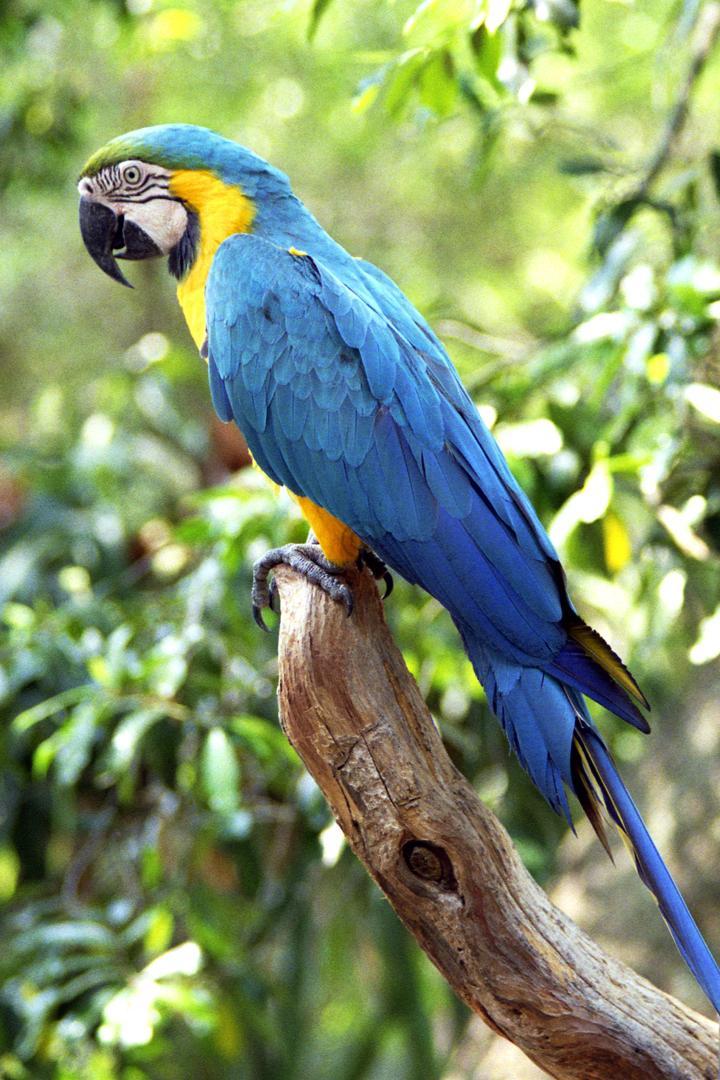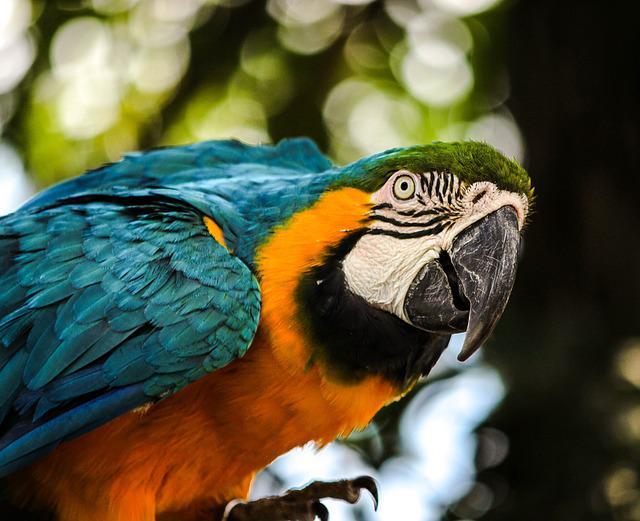The first image is the image on the left, the second image is the image on the right. For the images shown, is this caption "All birds shown have blue and yellow coloring, and at least one image has green fanning fronds in the background." true? Answer yes or no. No. The first image is the image on the left, the second image is the image on the right. Analyze the images presented: Is the assertion "There are at least two parrots in the right image." valid? Answer yes or no. No. 